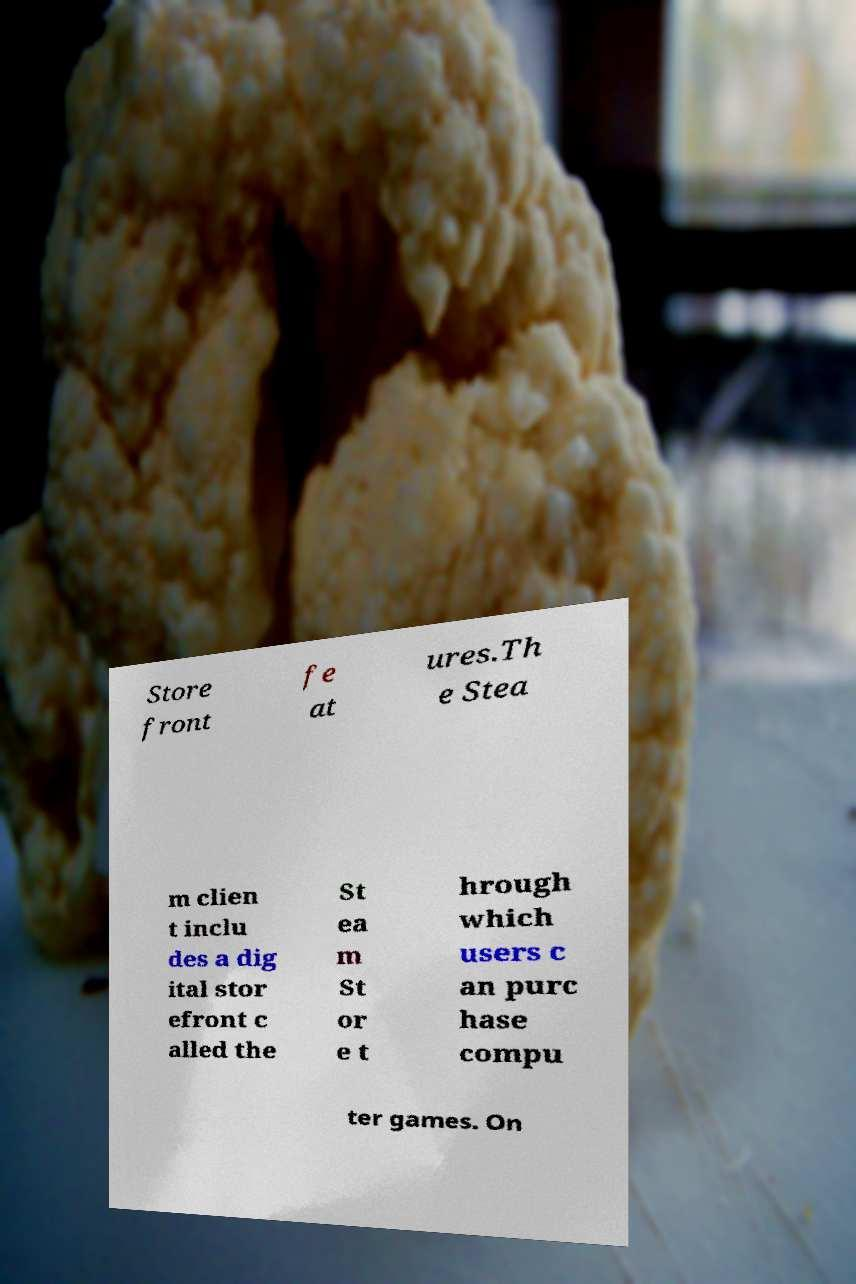There's text embedded in this image that I need extracted. Can you transcribe it verbatim? Store front fe at ures.Th e Stea m clien t inclu des a dig ital stor efront c alled the St ea m St or e t hrough which users c an purc hase compu ter games. On 